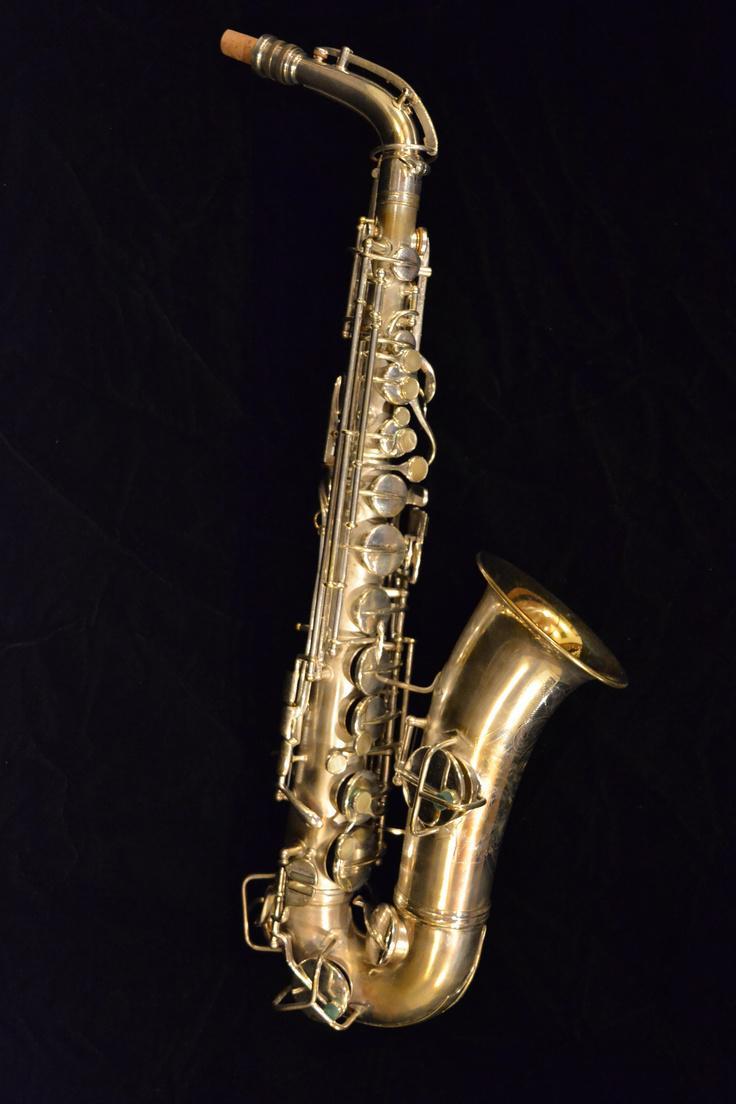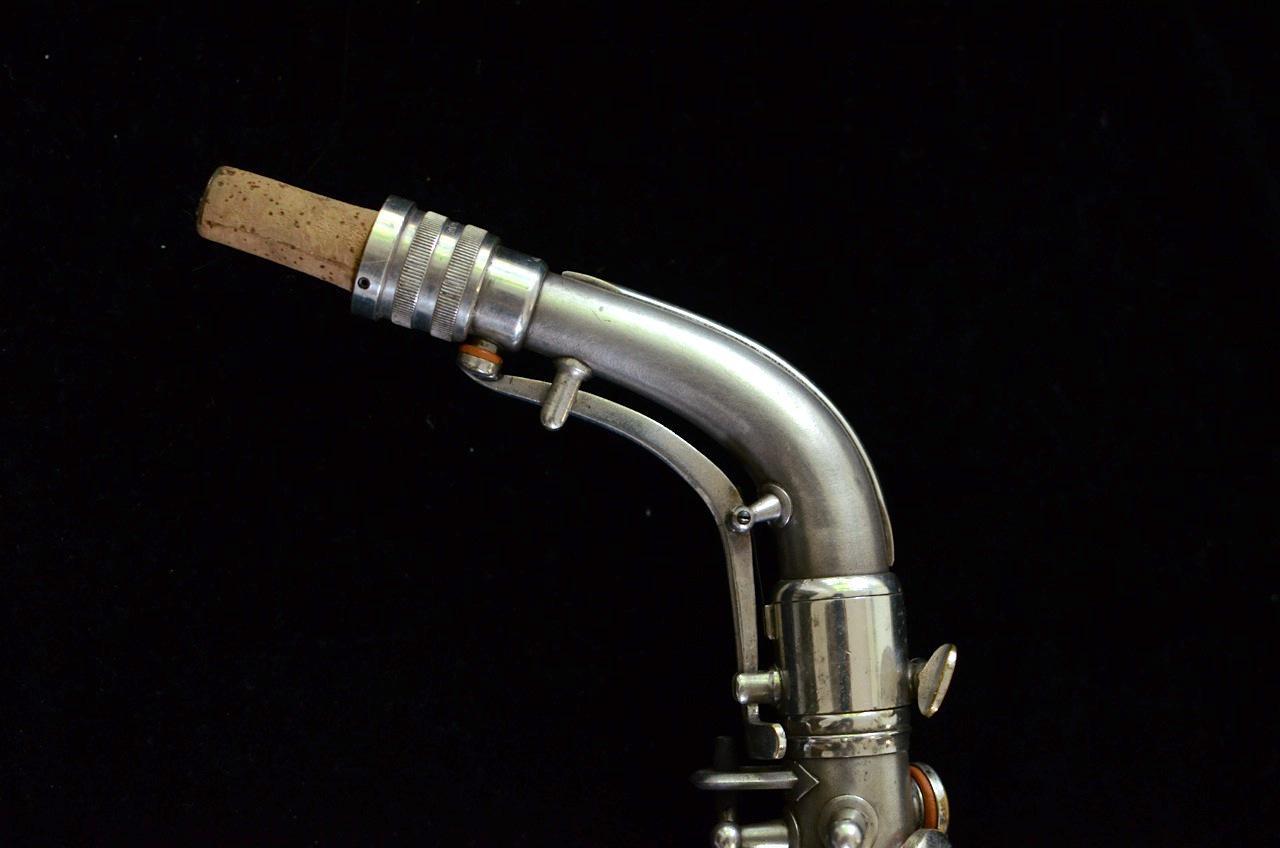The first image is the image on the left, the second image is the image on the right. Given the left and right images, does the statement "One image shows a saxophone with mouthpiece attached displayed on folds of blue velvet with its bell turned rightward." hold true? Answer yes or no. No. The first image is the image on the left, the second image is the image on the right. For the images shown, is this caption "The left and right image contains the same number saxophone and one if fully put together while the other is missing it's mouthpiece." true? Answer yes or no. No. 